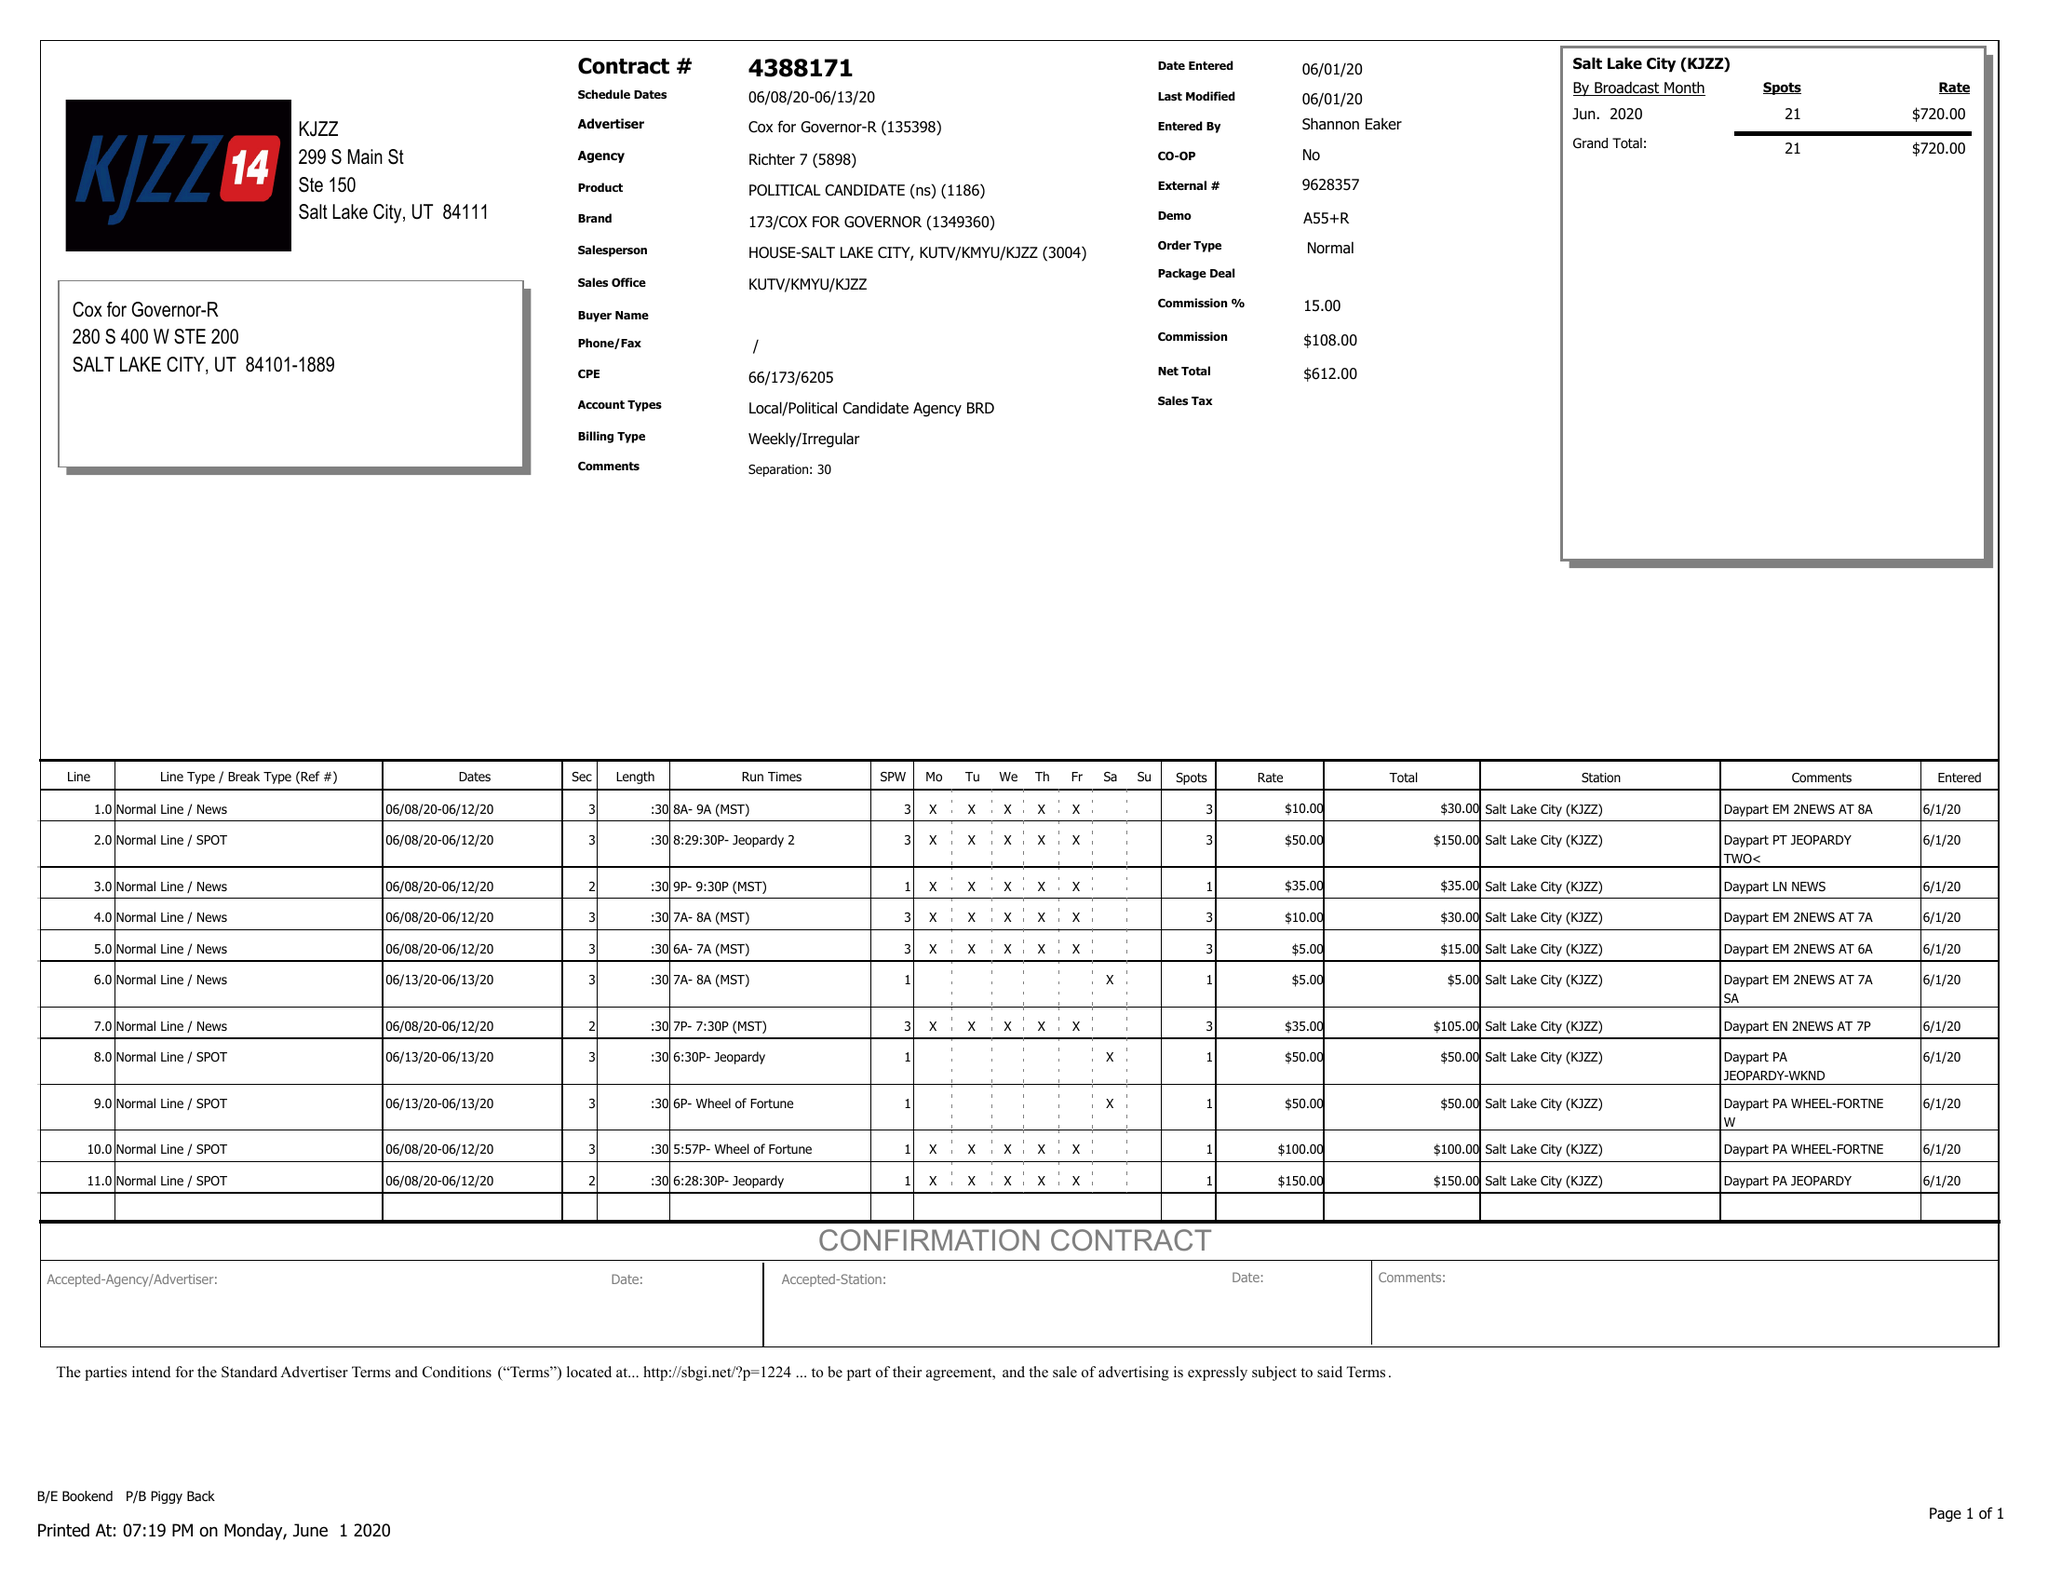What is the value for the contract_num?
Answer the question using a single word or phrase. 4388171 